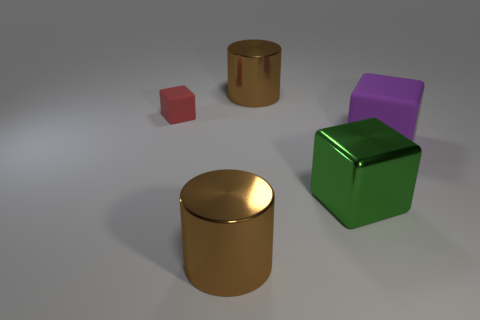Add 5 large brown shiny cylinders. How many objects exist? 10 Subtract all cylinders. How many objects are left? 3 Add 5 tiny metallic things. How many tiny metallic things exist? 5 Subtract 0 yellow cylinders. How many objects are left? 5 Subtract all tiny cubes. Subtract all purple blocks. How many objects are left? 3 Add 5 purple cubes. How many purple cubes are left? 6 